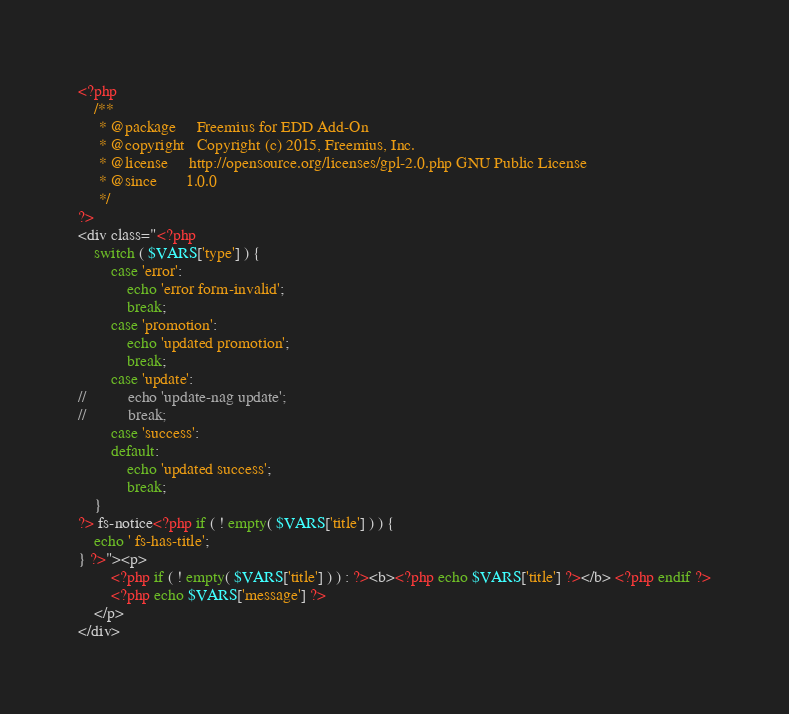<code> <loc_0><loc_0><loc_500><loc_500><_PHP_><?php
	/**
	 * @package     Freemius for EDD Add-On
	 * @copyright   Copyright (c) 2015, Freemius, Inc.
	 * @license     http://opensource.org/licenses/gpl-2.0.php GNU Public License
	 * @since       1.0.0
	 */
?>
<div class="<?php
	switch ( $VARS['type'] ) {
		case 'error':
			echo 'error form-invalid';
			break;
		case 'promotion':
			echo 'updated promotion';
			break;
		case 'update':
//			echo 'update-nag update';
//			break;
		case 'success':
		default:
			echo 'updated success';
			break;
	}
?> fs-notice<?php if ( ! empty( $VARS['title'] ) ) {
	echo ' fs-has-title';
} ?>"><p>
		<?php if ( ! empty( $VARS['title'] ) ) : ?><b><?php echo $VARS['title'] ?></b> <?php endif ?>
		<?php echo $VARS['message'] ?>
	</p>
</div>
</code> 